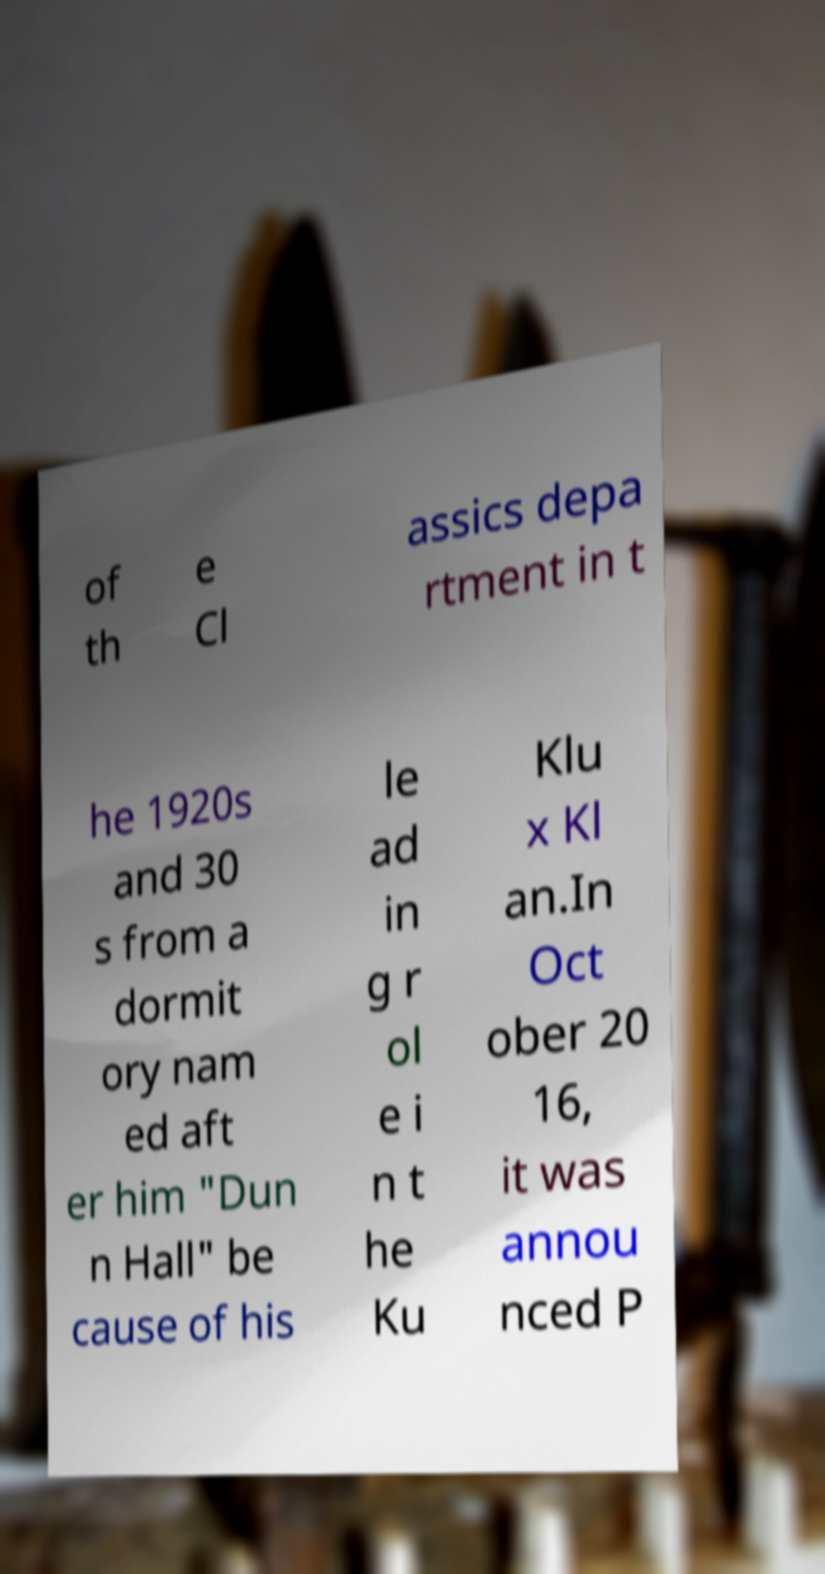What messages or text are displayed in this image? I need them in a readable, typed format. of th e Cl assics depa rtment in t he 1920s and 30 s from a dormit ory nam ed aft er him "Dun n Hall" be cause of his le ad in g r ol e i n t he Ku Klu x Kl an.In Oct ober 20 16, it was annou nced P 